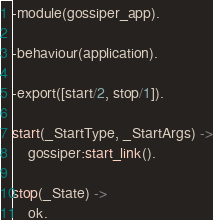<code> <loc_0><loc_0><loc_500><loc_500><_Erlang_>-module(gossiper_app).

-behaviour(application).

-export([start/2, stop/1]).

start(_StartType, _StartArgs) ->
    gossiper:start_link().

stop(_State) ->
    ok.
</code> 